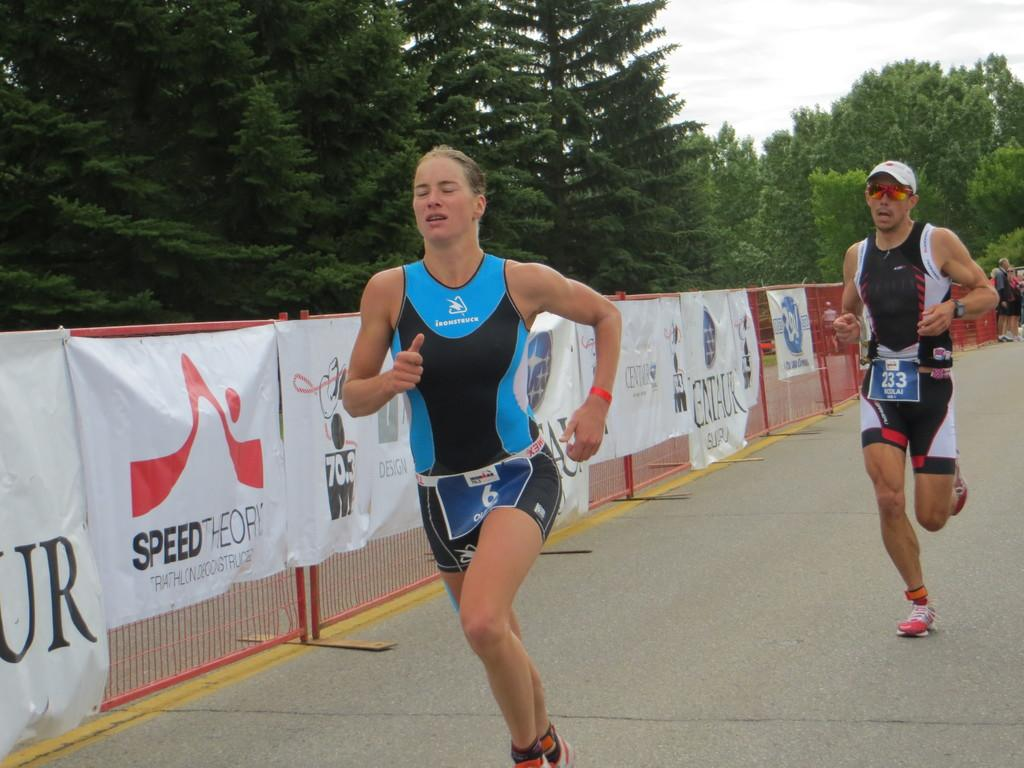<image>
Share a concise interpretation of the image provided. Runners runninng in front of a banner that says Speed Theory. 